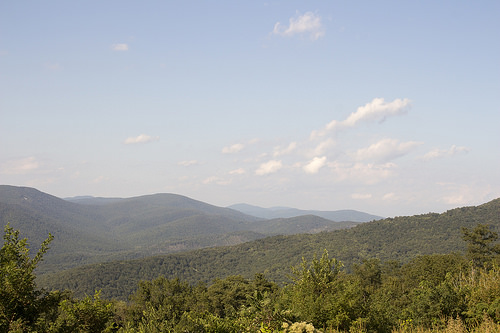<image>
Is there a sky behind the mountain? Yes. From this viewpoint, the sky is positioned behind the mountain, with the mountain partially or fully occluding the sky. 